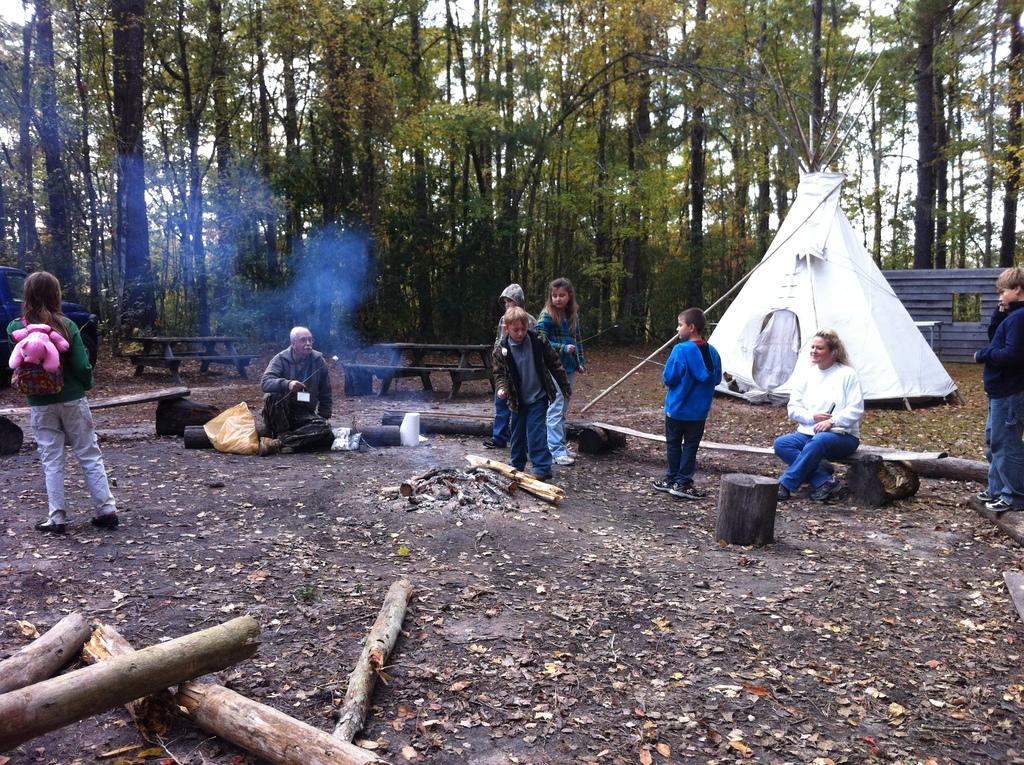How many people are present in the image? There are many people in the open ground in the image. What can be found on the ground in the image? There are woods on the ground in the image. What structure is present for warmth and gathering? There is a fireplace in the image. What type of shelter is visible in the background? In the background, there is a tent. What type of seating is available in the background? There are benches in the background. What type of natural feature is visible in the background? Trees are visible in the background. What type of scarf is being used to improve the acoustics in the image? There is no scarf present in the image, nor is there any mention of acoustics. What type of ship can be seen sailing in the background of the image? There is no ship present in the image; it features an open ground with people, woods, a fireplace, a tent, benches, and trees in the background. 